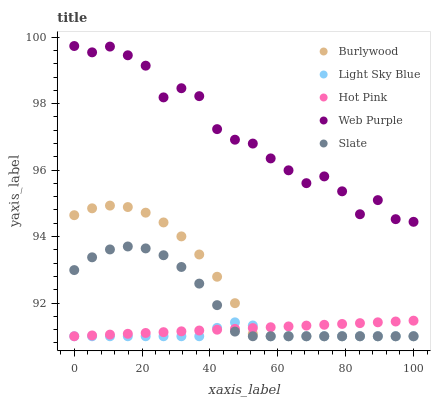Does Light Sky Blue have the minimum area under the curve?
Answer yes or no. Yes. Does Web Purple have the maximum area under the curve?
Answer yes or no. Yes. Does Web Purple have the minimum area under the curve?
Answer yes or no. No. Does Light Sky Blue have the maximum area under the curve?
Answer yes or no. No. Is Hot Pink the smoothest?
Answer yes or no. Yes. Is Web Purple the roughest?
Answer yes or no. Yes. Is Light Sky Blue the smoothest?
Answer yes or no. No. Is Light Sky Blue the roughest?
Answer yes or no. No. Does Burlywood have the lowest value?
Answer yes or no. Yes. Does Web Purple have the lowest value?
Answer yes or no. No. Does Web Purple have the highest value?
Answer yes or no. Yes. Does Light Sky Blue have the highest value?
Answer yes or no. No. Is Light Sky Blue less than Web Purple?
Answer yes or no. Yes. Is Web Purple greater than Slate?
Answer yes or no. Yes. Does Light Sky Blue intersect Slate?
Answer yes or no. Yes. Is Light Sky Blue less than Slate?
Answer yes or no. No. Is Light Sky Blue greater than Slate?
Answer yes or no. No. Does Light Sky Blue intersect Web Purple?
Answer yes or no. No. 